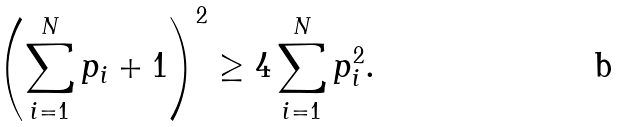Convert formula to latex. <formula><loc_0><loc_0><loc_500><loc_500>\left ( \sum ^ { N } _ { i = 1 } p _ { i } + 1 \right ) ^ { 2 } \geq 4 \sum ^ { N } _ { i = 1 } p _ { i } ^ { 2 } .</formula> 